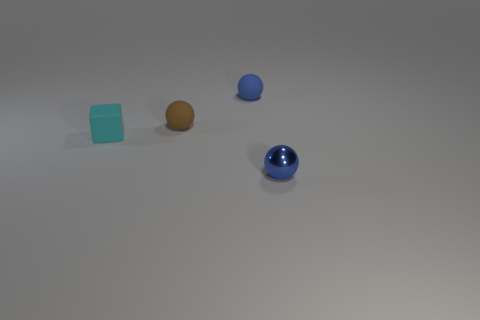Is there anything else of the same color as the small metallic sphere?
Offer a terse response. Yes. The brown object that is the same material as the cyan cube is what shape?
Your answer should be very brief. Sphere. There is a thing right of the small blue rubber sphere; how big is it?
Ensure brevity in your answer.  Small. What is the shape of the cyan object?
Provide a short and direct response. Cube. There is a blue object left of the tiny blue metallic sphere; is it the same size as the blue ball in front of the tiny brown matte thing?
Give a very brief answer. Yes. What is the size of the blue sphere behind the sphere on the right side of the small blue sphere that is behind the tiny cyan rubber block?
Provide a short and direct response. Small. There is a blue thing on the left side of the small blue sphere that is in front of the blue thing that is behind the tiny metallic thing; what shape is it?
Your answer should be very brief. Sphere. The small thing in front of the cyan object has what shape?
Provide a succinct answer. Sphere. Is the cyan cube made of the same material as the small blue thing that is behind the tiny blue shiny thing?
Your response must be concise. Yes. What number of other things are there of the same shape as the cyan rubber object?
Your response must be concise. 0. 